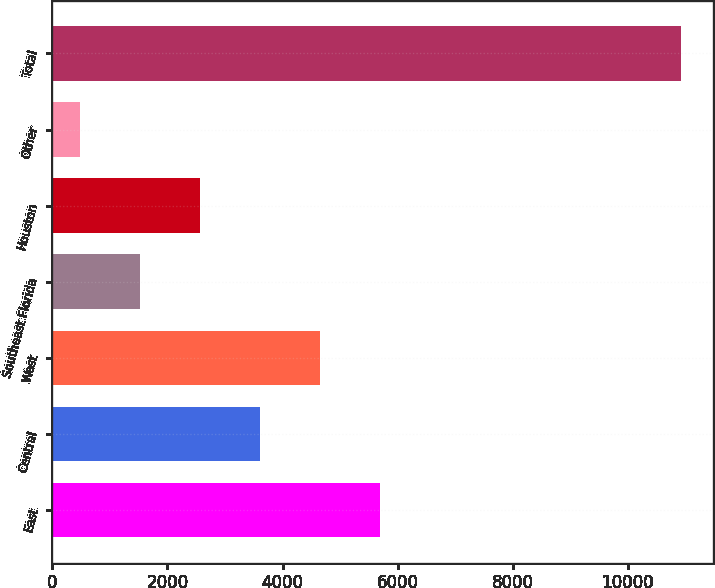Convert chart. <chart><loc_0><loc_0><loc_500><loc_500><bar_chart><fcel>East<fcel>Central<fcel>West<fcel>Southeast Florida<fcel>Houston<fcel>Other<fcel>Total<nl><fcel>5700.5<fcel>3609.5<fcel>4655<fcel>1518.5<fcel>2564<fcel>473<fcel>10928<nl></chart> 